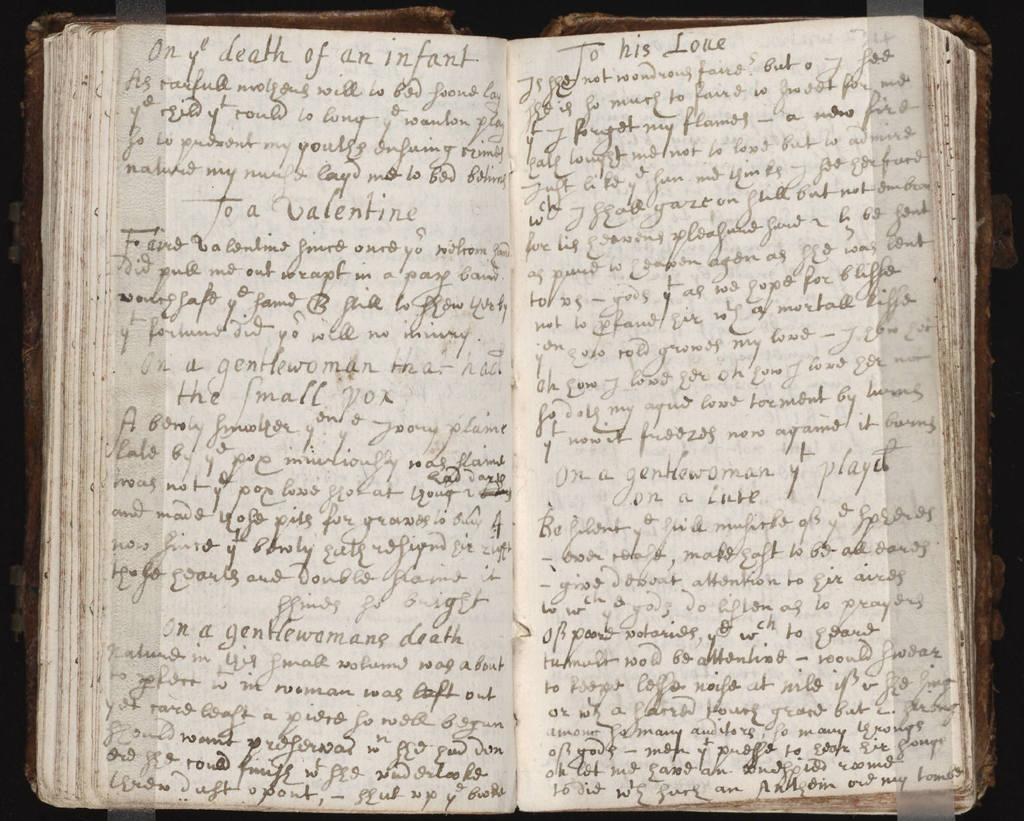Provide a one-sentence caption for the provided image. an open book or journal with handwritten pages that has words death of an infant at top of left page. 